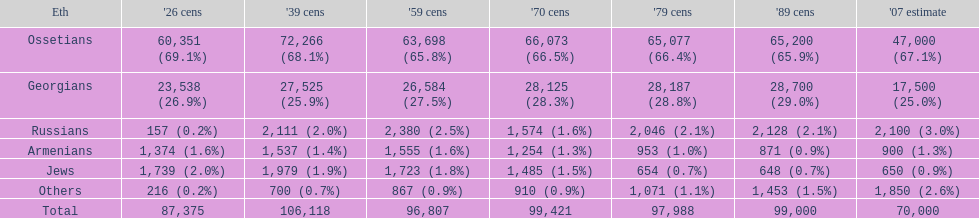How many ethnicity is there? 6. 